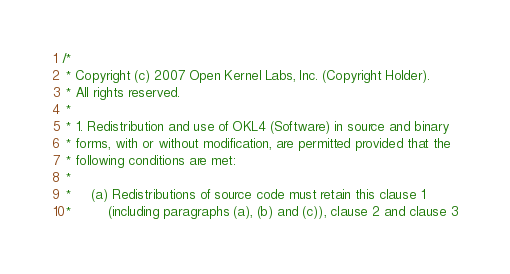<code> <loc_0><loc_0><loc_500><loc_500><_C_>/*
 * Copyright (c) 2007 Open Kernel Labs, Inc. (Copyright Holder).
 * All rights reserved.
 *
 * 1. Redistribution and use of OKL4 (Software) in source and binary
 * forms, with or without modification, are permitted provided that the
 * following conditions are met:
 *
 *     (a) Redistributions of source code must retain this clause 1
 *         (including paragraphs (a), (b) and (c)), clause 2 and clause 3</code> 